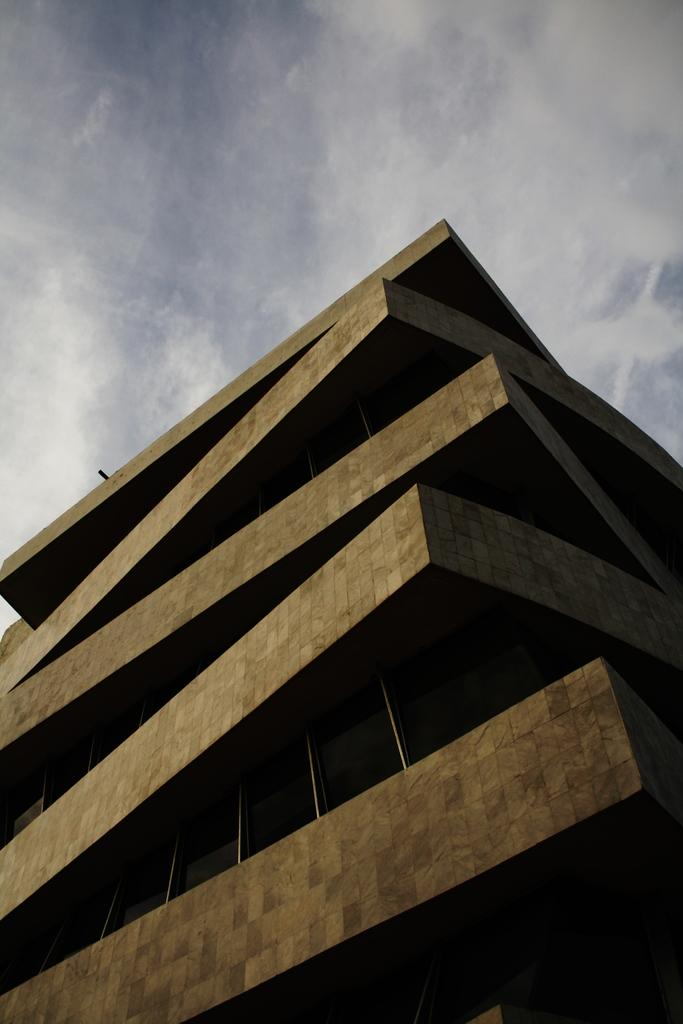What is the main subject of the image? The main subject of the image is a building. What can be seen in the background of the image? The sky is visible in the background of the image. What type of button is being used by the man in the image? There is no man or button present in the image; it only features a building and the sky. 